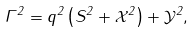<formula> <loc_0><loc_0><loc_500><loc_500>\Gamma ^ { 2 } = q ^ { 2 } \left ( S ^ { 2 } + \mathcal { X } ^ { 2 } \right ) + \mathcal { Y } ^ { 2 } ,</formula> 